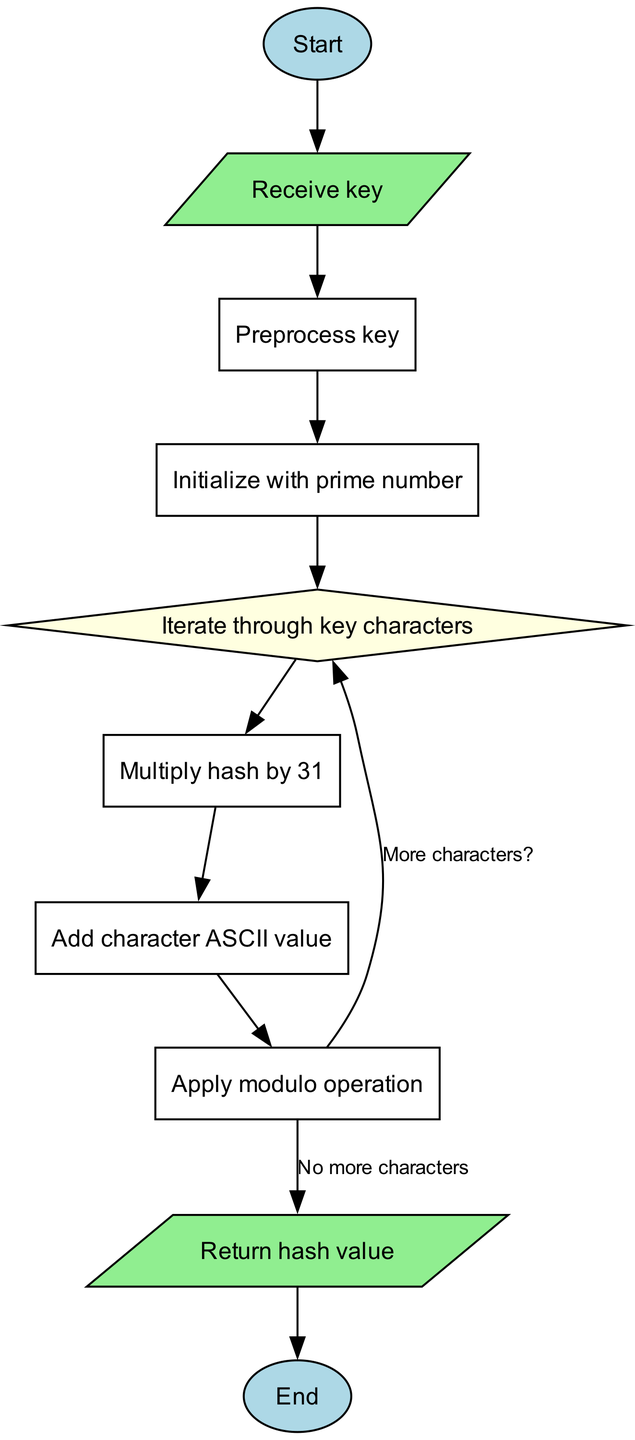What is the first node in the flowchart? The first node, as indicated in the diagram, is labeled 'Start'. This node is where the algorithm begins its execution.
Answer: Start How many nodes are present in the diagram? The diagram includes a total of ten nodes listed from 'Start' to 'End'. By counting all the individual nodes depicted in the diagram, the answer can be obtained.
Answer: 10 What is the label of the node that follows 'Receive key'? The node that follows 'Receive key' is labeled 'Preprocess key'. Following the sequence indicated in the flow of the diagram, this is the next action in the algorithm.
Answer: Preprocess key What operation is performed after the modulo operation if there are more characters? If there are more characters, the next operation performed is 'Iterate through key characters'. This is indicated by the edge labeled 'More characters?' which leads back to the 'Iterate' node.
Answer: Iterate through key characters What is the last operation before returning the hash value? The last operation before returning the hash value is 'Apply modulo operation'. This indicates that once all characters are processed, the last step involves the modulo operation before heading to return.
Answer: Apply modulo operation Which node represents a decision point in the flowchart? The decision point in the flowchart is represented by the node labeled 'Iterate through key characters'. In diagrams like these, this diamond-shaped node signifies a choice or condition that affects the direction of the flow.
Answer: Iterate through key characters How does the algorithm handle character processing? The algorithm handles character processing by iterating through key characters and subsequently adding the character's ASCII value after multiplying the hash value by 31, as seen in the series of operations connected to the 'Iterate' node.
Answer: Iterates through key characters What are the shapes of the nodes used for 'Start' and 'End'? The shapes of the nodes used for 'Start' and 'End' are ovals, which are distinct in the diagram for representing entry and exit points in the flowchart.
Answer: Oval 